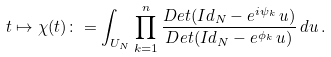<formula> <loc_0><loc_0><loc_500><loc_500>t \mapsto \chi ( t ) \colon = \int _ { U _ { N } } \prod _ { k = 1 } ^ { n } \frac { D e t ( I d _ { N } - e ^ { i \psi _ { k } } \, u ) } { D e t ( I d _ { N } - e ^ { \phi _ { k } } \, u ) } \, d u \, .</formula> 